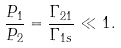Convert formula to latex. <formula><loc_0><loc_0><loc_500><loc_500>\frac { P _ { 1 } } { P _ { 2 } } = \frac { \Gamma _ { 2 1 } } { \Gamma _ { 1 s } } \ll 1 .</formula> 